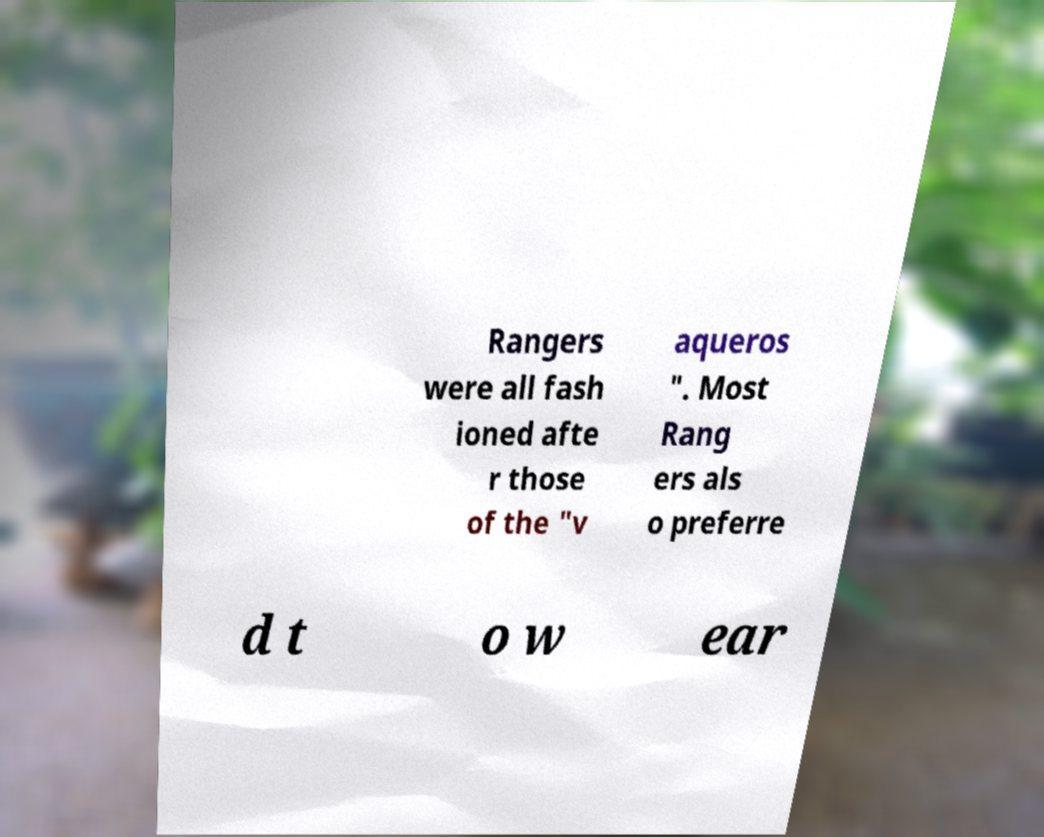Can you accurately transcribe the text from the provided image for me? Rangers were all fash ioned afte r those of the "v aqueros ". Most Rang ers als o preferre d t o w ear 